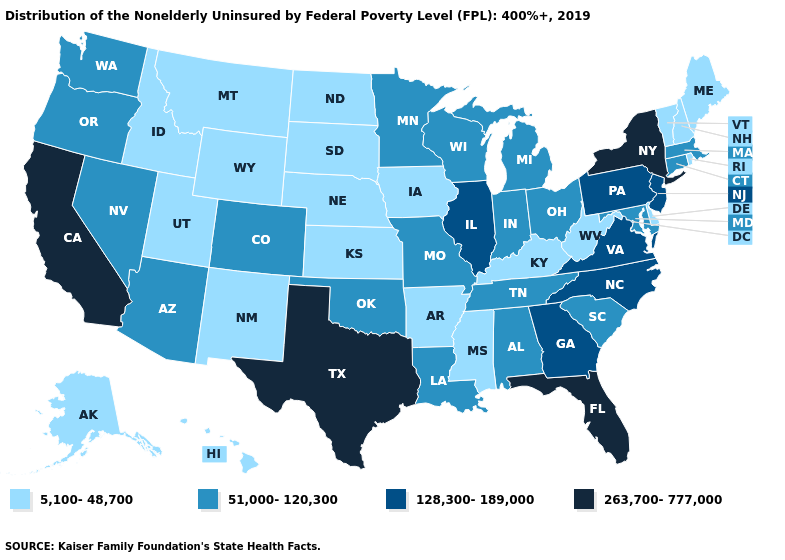What is the value of Arizona?
Give a very brief answer. 51,000-120,300. What is the value of Texas?
Give a very brief answer. 263,700-777,000. Among the states that border New Mexico , does Arizona have the lowest value?
Concise answer only. No. What is the value of Texas?
Concise answer only. 263,700-777,000. What is the lowest value in the MidWest?
Answer briefly. 5,100-48,700. Among the states that border Oregon , which have the highest value?
Short answer required. California. Which states have the lowest value in the USA?
Give a very brief answer. Alaska, Arkansas, Delaware, Hawaii, Idaho, Iowa, Kansas, Kentucky, Maine, Mississippi, Montana, Nebraska, New Hampshire, New Mexico, North Dakota, Rhode Island, South Dakota, Utah, Vermont, West Virginia, Wyoming. Which states have the lowest value in the USA?
Be succinct. Alaska, Arkansas, Delaware, Hawaii, Idaho, Iowa, Kansas, Kentucky, Maine, Mississippi, Montana, Nebraska, New Hampshire, New Mexico, North Dakota, Rhode Island, South Dakota, Utah, Vermont, West Virginia, Wyoming. What is the value of New Mexico?
Write a very short answer. 5,100-48,700. What is the value of Connecticut?
Be succinct. 51,000-120,300. Does Maryland have the lowest value in the USA?
Quick response, please. No. What is the value of Utah?
Keep it brief. 5,100-48,700. Does the map have missing data?
Keep it brief. No. Among the states that border Arkansas , which have the highest value?
Short answer required. Texas. Name the states that have a value in the range 128,300-189,000?
Short answer required. Georgia, Illinois, New Jersey, North Carolina, Pennsylvania, Virginia. 